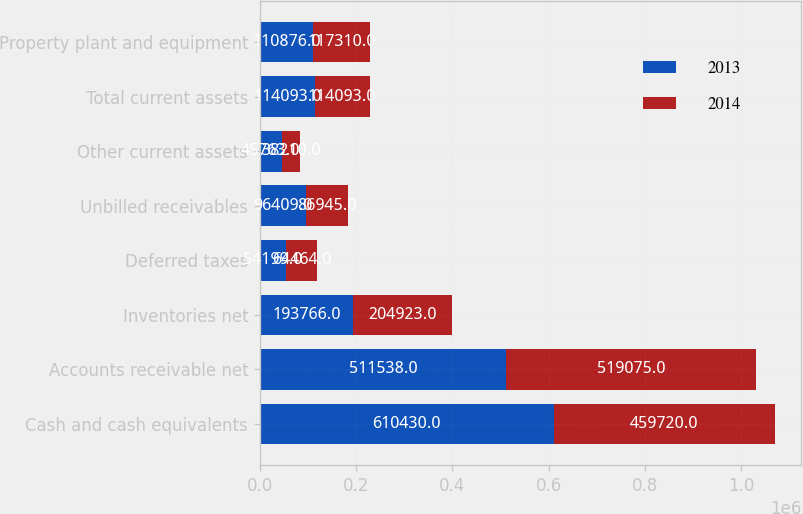Convert chart to OTSL. <chart><loc_0><loc_0><loc_500><loc_500><stacked_bar_chart><ecel><fcel>Cash and cash equivalents<fcel>Accounts receivable net<fcel>Inventories net<fcel>Deferred taxes<fcel>Unbilled receivables<fcel>Other current assets<fcel>Total current assets<fcel>Property plant and equipment<nl><fcel>2013<fcel>610430<fcel>511538<fcel>193766<fcel>54199<fcel>96409<fcel>45763<fcel>114093<fcel>110876<nl><fcel>2014<fcel>459720<fcel>519075<fcel>204923<fcel>64464<fcel>86945<fcel>38210<fcel>114093<fcel>117310<nl></chart> 